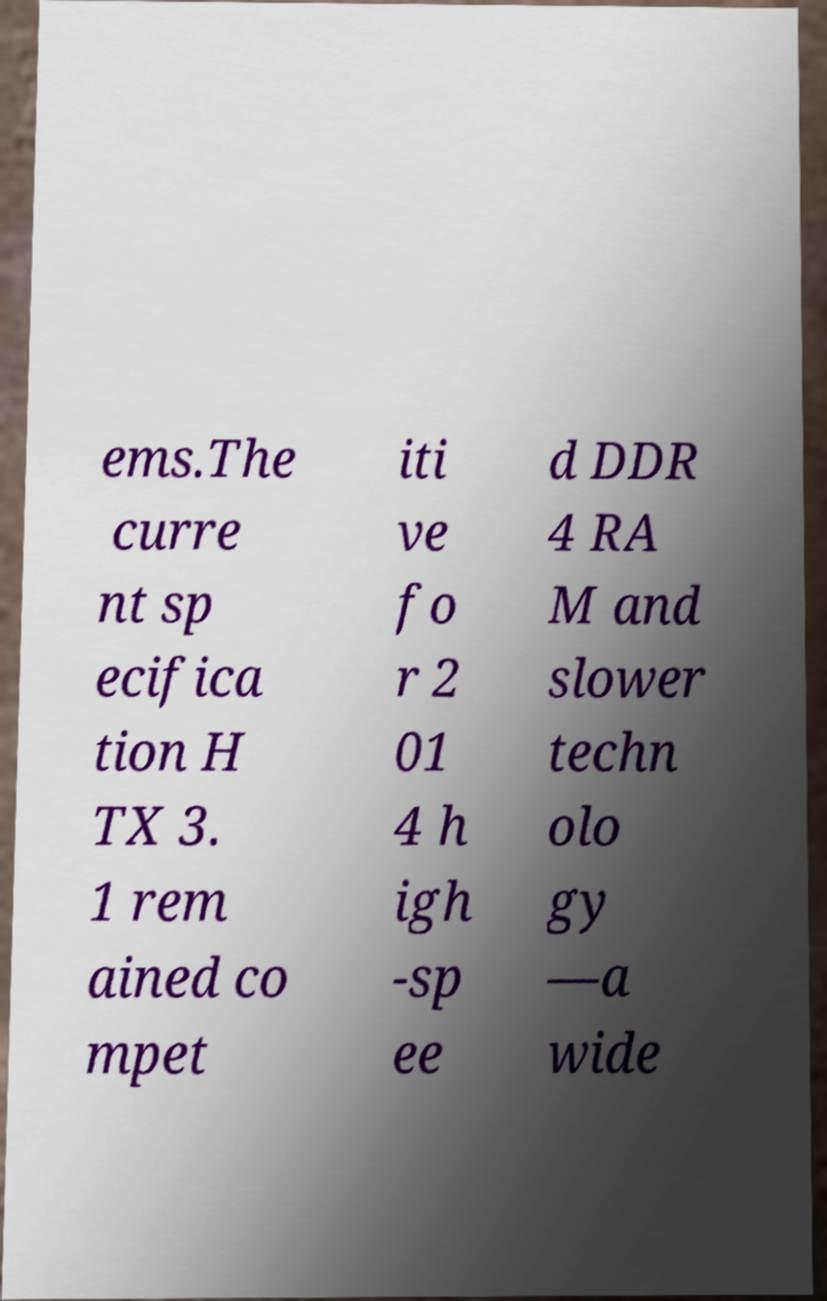I need the written content from this picture converted into text. Can you do that? ems.The curre nt sp ecifica tion H TX 3. 1 rem ained co mpet iti ve fo r 2 01 4 h igh -sp ee d DDR 4 RA M and slower techn olo gy —a wide 